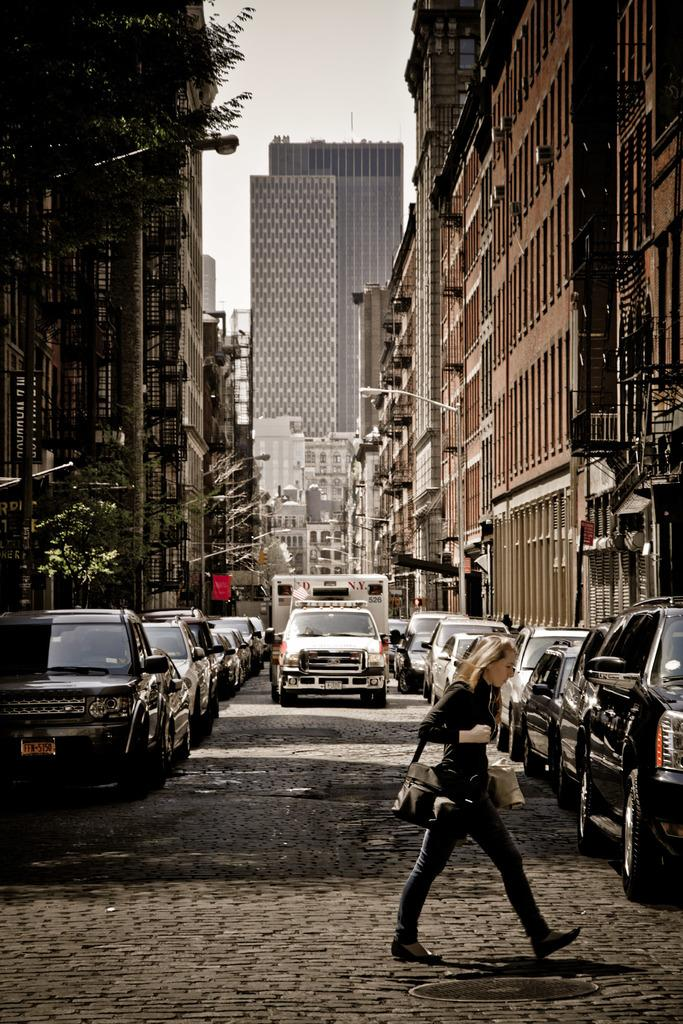<image>
Give a short and clear explanation of the subsequent image. A parked car on the left has FFN-5150 on the plate. 